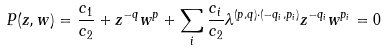<formula> <loc_0><loc_0><loc_500><loc_500>P ( z , w ) = \frac { c _ { 1 } } { c _ { 2 } } + z ^ { - q } w ^ { p } + \sum _ { i } \frac { c _ { i } } { c _ { 2 } } \lambda ^ { ( p , q ) \cdot ( - q _ { i } , p _ { i } ) } z ^ { - q _ { i } } w ^ { p _ { i } } = 0</formula> 